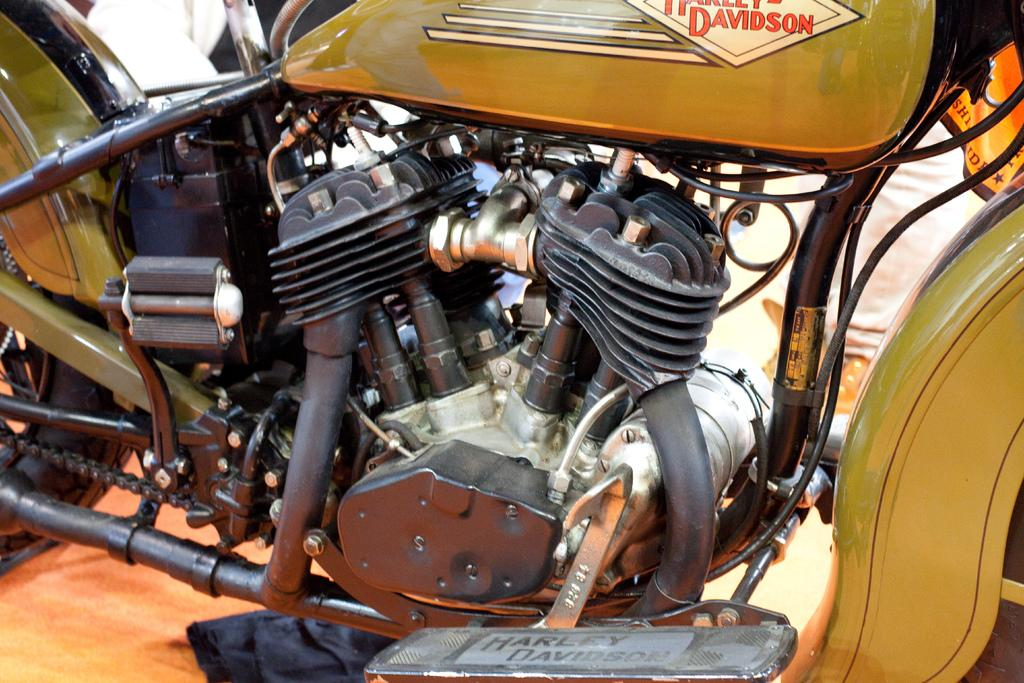What type of engine is depicted in the image? The image contains an engine of a motorcycle. What specific features can be seen on the engine? The engine has pipes, wires, a gear rod, a chain, part of a tire, and a diesel tank. Is there any branding on the engine? Yes, the name "Harley Davidson" is present on the engine. What type of calendar is hanging on the wall near the engine? There is no calendar present in the image; it only features the engine of a motorcycle. What role does the lead play in the functioning of the engine? There is no mention of lead in the image or the provided facts, and it is not a component of the engine. 